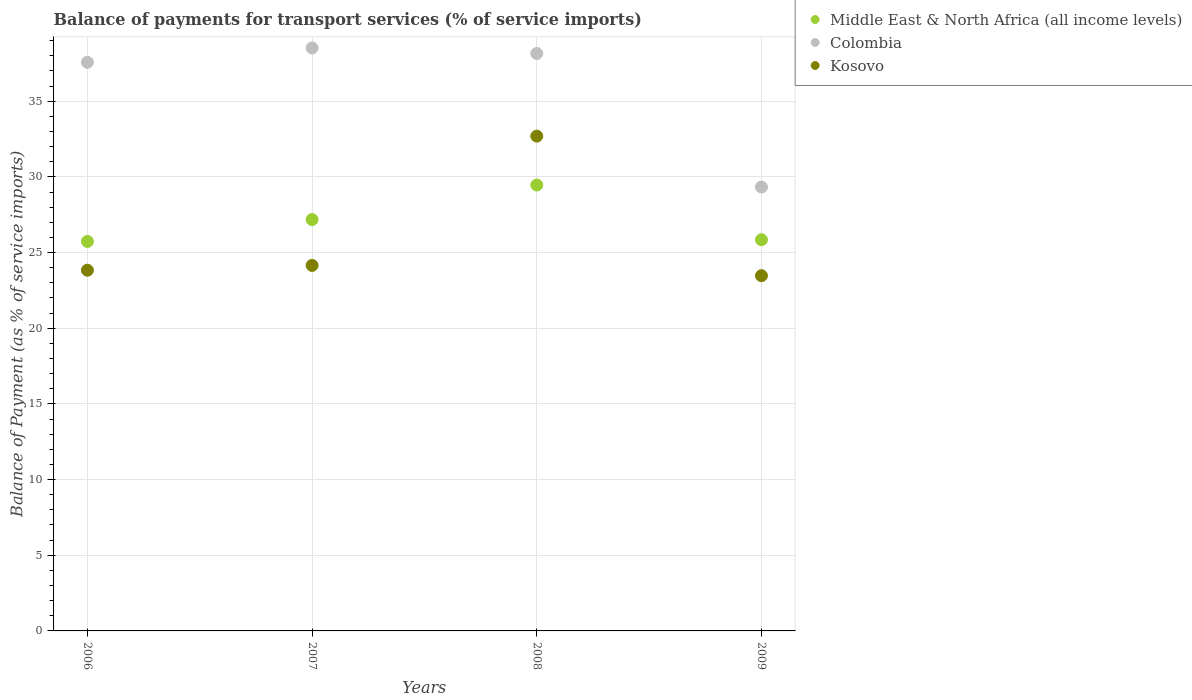How many different coloured dotlines are there?
Give a very brief answer. 3. What is the balance of payments for transport services in Middle East & North Africa (all income levels) in 2006?
Offer a terse response. 25.74. Across all years, what is the maximum balance of payments for transport services in Middle East & North Africa (all income levels)?
Your answer should be very brief. 29.46. Across all years, what is the minimum balance of payments for transport services in Kosovo?
Your response must be concise. 23.47. In which year was the balance of payments for transport services in Middle East & North Africa (all income levels) maximum?
Offer a very short reply. 2008. What is the total balance of payments for transport services in Colombia in the graph?
Provide a short and direct response. 143.58. What is the difference between the balance of payments for transport services in Middle East & North Africa (all income levels) in 2008 and that in 2009?
Provide a succinct answer. 3.61. What is the difference between the balance of payments for transport services in Middle East & North Africa (all income levels) in 2006 and the balance of payments for transport services in Colombia in 2009?
Ensure brevity in your answer.  -3.59. What is the average balance of payments for transport services in Kosovo per year?
Your response must be concise. 26.04. In the year 2009, what is the difference between the balance of payments for transport services in Middle East & North Africa (all income levels) and balance of payments for transport services in Colombia?
Your response must be concise. -3.48. What is the ratio of the balance of payments for transport services in Colombia in 2007 to that in 2008?
Give a very brief answer. 1.01. Is the difference between the balance of payments for transport services in Middle East & North Africa (all income levels) in 2008 and 2009 greater than the difference between the balance of payments for transport services in Colombia in 2008 and 2009?
Make the answer very short. No. What is the difference between the highest and the second highest balance of payments for transport services in Kosovo?
Make the answer very short. 8.54. What is the difference between the highest and the lowest balance of payments for transport services in Colombia?
Offer a terse response. 9.19. In how many years, is the balance of payments for transport services in Kosovo greater than the average balance of payments for transport services in Kosovo taken over all years?
Give a very brief answer. 1. Is the sum of the balance of payments for transport services in Middle East & North Africa (all income levels) in 2008 and 2009 greater than the maximum balance of payments for transport services in Colombia across all years?
Keep it short and to the point. Yes. Is it the case that in every year, the sum of the balance of payments for transport services in Colombia and balance of payments for transport services in Kosovo  is greater than the balance of payments for transport services in Middle East & North Africa (all income levels)?
Ensure brevity in your answer.  Yes. Does the balance of payments for transport services in Colombia monotonically increase over the years?
Offer a very short reply. No. Is the balance of payments for transport services in Colombia strictly greater than the balance of payments for transport services in Middle East & North Africa (all income levels) over the years?
Your response must be concise. Yes. What is the difference between two consecutive major ticks on the Y-axis?
Offer a very short reply. 5. Are the values on the major ticks of Y-axis written in scientific E-notation?
Give a very brief answer. No. How many legend labels are there?
Give a very brief answer. 3. What is the title of the graph?
Your response must be concise. Balance of payments for transport services (% of service imports). What is the label or title of the X-axis?
Keep it short and to the point. Years. What is the label or title of the Y-axis?
Keep it short and to the point. Balance of Payment (as % of service imports). What is the Balance of Payment (as % of service imports) in Middle East & North Africa (all income levels) in 2006?
Offer a very short reply. 25.74. What is the Balance of Payment (as % of service imports) of Colombia in 2006?
Offer a very short reply. 37.57. What is the Balance of Payment (as % of service imports) of Kosovo in 2006?
Your answer should be compact. 23.83. What is the Balance of Payment (as % of service imports) of Middle East & North Africa (all income levels) in 2007?
Keep it short and to the point. 27.18. What is the Balance of Payment (as % of service imports) in Colombia in 2007?
Give a very brief answer. 38.52. What is the Balance of Payment (as % of service imports) in Kosovo in 2007?
Keep it short and to the point. 24.15. What is the Balance of Payment (as % of service imports) in Middle East & North Africa (all income levels) in 2008?
Provide a succinct answer. 29.46. What is the Balance of Payment (as % of service imports) in Colombia in 2008?
Make the answer very short. 38.15. What is the Balance of Payment (as % of service imports) in Kosovo in 2008?
Offer a terse response. 32.7. What is the Balance of Payment (as % of service imports) in Middle East & North Africa (all income levels) in 2009?
Offer a very short reply. 25.85. What is the Balance of Payment (as % of service imports) in Colombia in 2009?
Your answer should be compact. 29.33. What is the Balance of Payment (as % of service imports) of Kosovo in 2009?
Provide a short and direct response. 23.47. Across all years, what is the maximum Balance of Payment (as % of service imports) in Middle East & North Africa (all income levels)?
Your answer should be compact. 29.46. Across all years, what is the maximum Balance of Payment (as % of service imports) of Colombia?
Give a very brief answer. 38.52. Across all years, what is the maximum Balance of Payment (as % of service imports) in Kosovo?
Keep it short and to the point. 32.7. Across all years, what is the minimum Balance of Payment (as % of service imports) in Middle East & North Africa (all income levels)?
Provide a short and direct response. 25.74. Across all years, what is the minimum Balance of Payment (as % of service imports) in Colombia?
Your response must be concise. 29.33. Across all years, what is the minimum Balance of Payment (as % of service imports) of Kosovo?
Offer a very short reply. 23.47. What is the total Balance of Payment (as % of service imports) of Middle East & North Africa (all income levels) in the graph?
Provide a succinct answer. 108.23. What is the total Balance of Payment (as % of service imports) in Colombia in the graph?
Your answer should be very brief. 143.58. What is the total Balance of Payment (as % of service imports) in Kosovo in the graph?
Keep it short and to the point. 104.15. What is the difference between the Balance of Payment (as % of service imports) in Middle East & North Africa (all income levels) in 2006 and that in 2007?
Give a very brief answer. -1.44. What is the difference between the Balance of Payment (as % of service imports) in Colombia in 2006 and that in 2007?
Offer a terse response. -0.95. What is the difference between the Balance of Payment (as % of service imports) in Kosovo in 2006 and that in 2007?
Provide a short and direct response. -0.32. What is the difference between the Balance of Payment (as % of service imports) of Middle East & North Africa (all income levels) in 2006 and that in 2008?
Give a very brief answer. -3.73. What is the difference between the Balance of Payment (as % of service imports) in Colombia in 2006 and that in 2008?
Offer a terse response. -0.58. What is the difference between the Balance of Payment (as % of service imports) of Kosovo in 2006 and that in 2008?
Keep it short and to the point. -8.86. What is the difference between the Balance of Payment (as % of service imports) in Middle East & North Africa (all income levels) in 2006 and that in 2009?
Your answer should be compact. -0.11. What is the difference between the Balance of Payment (as % of service imports) in Colombia in 2006 and that in 2009?
Give a very brief answer. 8.25. What is the difference between the Balance of Payment (as % of service imports) of Kosovo in 2006 and that in 2009?
Your response must be concise. 0.36. What is the difference between the Balance of Payment (as % of service imports) in Middle East & North Africa (all income levels) in 2007 and that in 2008?
Offer a very short reply. -2.28. What is the difference between the Balance of Payment (as % of service imports) in Colombia in 2007 and that in 2008?
Give a very brief answer. 0.37. What is the difference between the Balance of Payment (as % of service imports) in Kosovo in 2007 and that in 2008?
Provide a short and direct response. -8.54. What is the difference between the Balance of Payment (as % of service imports) in Middle East & North Africa (all income levels) in 2007 and that in 2009?
Your answer should be very brief. 1.33. What is the difference between the Balance of Payment (as % of service imports) of Colombia in 2007 and that in 2009?
Keep it short and to the point. 9.19. What is the difference between the Balance of Payment (as % of service imports) in Kosovo in 2007 and that in 2009?
Provide a succinct answer. 0.68. What is the difference between the Balance of Payment (as % of service imports) of Middle East & North Africa (all income levels) in 2008 and that in 2009?
Provide a succinct answer. 3.61. What is the difference between the Balance of Payment (as % of service imports) of Colombia in 2008 and that in 2009?
Your answer should be very brief. 8.83. What is the difference between the Balance of Payment (as % of service imports) of Kosovo in 2008 and that in 2009?
Give a very brief answer. 9.22. What is the difference between the Balance of Payment (as % of service imports) of Middle East & North Africa (all income levels) in 2006 and the Balance of Payment (as % of service imports) of Colombia in 2007?
Ensure brevity in your answer.  -12.78. What is the difference between the Balance of Payment (as % of service imports) of Middle East & North Africa (all income levels) in 2006 and the Balance of Payment (as % of service imports) of Kosovo in 2007?
Provide a succinct answer. 1.58. What is the difference between the Balance of Payment (as % of service imports) in Colombia in 2006 and the Balance of Payment (as % of service imports) in Kosovo in 2007?
Make the answer very short. 13.42. What is the difference between the Balance of Payment (as % of service imports) of Middle East & North Africa (all income levels) in 2006 and the Balance of Payment (as % of service imports) of Colombia in 2008?
Offer a very short reply. -12.42. What is the difference between the Balance of Payment (as % of service imports) of Middle East & North Africa (all income levels) in 2006 and the Balance of Payment (as % of service imports) of Kosovo in 2008?
Your answer should be compact. -6.96. What is the difference between the Balance of Payment (as % of service imports) in Colombia in 2006 and the Balance of Payment (as % of service imports) in Kosovo in 2008?
Provide a succinct answer. 4.88. What is the difference between the Balance of Payment (as % of service imports) of Middle East & North Africa (all income levels) in 2006 and the Balance of Payment (as % of service imports) of Colombia in 2009?
Give a very brief answer. -3.59. What is the difference between the Balance of Payment (as % of service imports) of Middle East & North Africa (all income levels) in 2006 and the Balance of Payment (as % of service imports) of Kosovo in 2009?
Your response must be concise. 2.26. What is the difference between the Balance of Payment (as % of service imports) of Colombia in 2006 and the Balance of Payment (as % of service imports) of Kosovo in 2009?
Give a very brief answer. 14.1. What is the difference between the Balance of Payment (as % of service imports) in Middle East & North Africa (all income levels) in 2007 and the Balance of Payment (as % of service imports) in Colombia in 2008?
Your answer should be very brief. -10.97. What is the difference between the Balance of Payment (as % of service imports) of Middle East & North Africa (all income levels) in 2007 and the Balance of Payment (as % of service imports) of Kosovo in 2008?
Your answer should be very brief. -5.52. What is the difference between the Balance of Payment (as % of service imports) in Colombia in 2007 and the Balance of Payment (as % of service imports) in Kosovo in 2008?
Your response must be concise. 5.82. What is the difference between the Balance of Payment (as % of service imports) in Middle East & North Africa (all income levels) in 2007 and the Balance of Payment (as % of service imports) in Colombia in 2009?
Make the answer very short. -2.15. What is the difference between the Balance of Payment (as % of service imports) of Middle East & North Africa (all income levels) in 2007 and the Balance of Payment (as % of service imports) of Kosovo in 2009?
Your response must be concise. 3.71. What is the difference between the Balance of Payment (as % of service imports) in Colombia in 2007 and the Balance of Payment (as % of service imports) in Kosovo in 2009?
Provide a succinct answer. 15.05. What is the difference between the Balance of Payment (as % of service imports) of Middle East & North Africa (all income levels) in 2008 and the Balance of Payment (as % of service imports) of Colombia in 2009?
Make the answer very short. 0.14. What is the difference between the Balance of Payment (as % of service imports) of Middle East & North Africa (all income levels) in 2008 and the Balance of Payment (as % of service imports) of Kosovo in 2009?
Provide a succinct answer. 5.99. What is the difference between the Balance of Payment (as % of service imports) in Colombia in 2008 and the Balance of Payment (as % of service imports) in Kosovo in 2009?
Your answer should be very brief. 14.68. What is the average Balance of Payment (as % of service imports) of Middle East & North Africa (all income levels) per year?
Ensure brevity in your answer.  27.06. What is the average Balance of Payment (as % of service imports) in Colombia per year?
Offer a terse response. 35.89. What is the average Balance of Payment (as % of service imports) of Kosovo per year?
Provide a short and direct response. 26.04. In the year 2006, what is the difference between the Balance of Payment (as % of service imports) of Middle East & North Africa (all income levels) and Balance of Payment (as % of service imports) of Colombia?
Provide a succinct answer. -11.84. In the year 2006, what is the difference between the Balance of Payment (as % of service imports) in Middle East & North Africa (all income levels) and Balance of Payment (as % of service imports) in Kosovo?
Ensure brevity in your answer.  1.9. In the year 2006, what is the difference between the Balance of Payment (as % of service imports) of Colombia and Balance of Payment (as % of service imports) of Kosovo?
Offer a terse response. 13.74. In the year 2007, what is the difference between the Balance of Payment (as % of service imports) in Middle East & North Africa (all income levels) and Balance of Payment (as % of service imports) in Colombia?
Ensure brevity in your answer.  -11.34. In the year 2007, what is the difference between the Balance of Payment (as % of service imports) of Middle East & North Africa (all income levels) and Balance of Payment (as % of service imports) of Kosovo?
Keep it short and to the point. 3.03. In the year 2007, what is the difference between the Balance of Payment (as % of service imports) in Colombia and Balance of Payment (as % of service imports) in Kosovo?
Your response must be concise. 14.37. In the year 2008, what is the difference between the Balance of Payment (as % of service imports) of Middle East & North Africa (all income levels) and Balance of Payment (as % of service imports) of Colombia?
Your answer should be compact. -8.69. In the year 2008, what is the difference between the Balance of Payment (as % of service imports) of Middle East & North Africa (all income levels) and Balance of Payment (as % of service imports) of Kosovo?
Ensure brevity in your answer.  -3.23. In the year 2008, what is the difference between the Balance of Payment (as % of service imports) in Colombia and Balance of Payment (as % of service imports) in Kosovo?
Provide a succinct answer. 5.46. In the year 2009, what is the difference between the Balance of Payment (as % of service imports) in Middle East & North Africa (all income levels) and Balance of Payment (as % of service imports) in Colombia?
Offer a very short reply. -3.48. In the year 2009, what is the difference between the Balance of Payment (as % of service imports) in Middle East & North Africa (all income levels) and Balance of Payment (as % of service imports) in Kosovo?
Keep it short and to the point. 2.38. In the year 2009, what is the difference between the Balance of Payment (as % of service imports) in Colombia and Balance of Payment (as % of service imports) in Kosovo?
Ensure brevity in your answer.  5.86. What is the ratio of the Balance of Payment (as % of service imports) of Middle East & North Africa (all income levels) in 2006 to that in 2007?
Your response must be concise. 0.95. What is the ratio of the Balance of Payment (as % of service imports) in Colombia in 2006 to that in 2007?
Your answer should be compact. 0.98. What is the ratio of the Balance of Payment (as % of service imports) of Middle East & North Africa (all income levels) in 2006 to that in 2008?
Make the answer very short. 0.87. What is the ratio of the Balance of Payment (as % of service imports) of Colombia in 2006 to that in 2008?
Provide a succinct answer. 0.98. What is the ratio of the Balance of Payment (as % of service imports) of Kosovo in 2006 to that in 2008?
Provide a succinct answer. 0.73. What is the ratio of the Balance of Payment (as % of service imports) in Colombia in 2006 to that in 2009?
Your answer should be very brief. 1.28. What is the ratio of the Balance of Payment (as % of service imports) of Kosovo in 2006 to that in 2009?
Provide a succinct answer. 1.02. What is the ratio of the Balance of Payment (as % of service imports) in Middle East & North Africa (all income levels) in 2007 to that in 2008?
Ensure brevity in your answer.  0.92. What is the ratio of the Balance of Payment (as % of service imports) in Colombia in 2007 to that in 2008?
Ensure brevity in your answer.  1.01. What is the ratio of the Balance of Payment (as % of service imports) of Kosovo in 2007 to that in 2008?
Keep it short and to the point. 0.74. What is the ratio of the Balance of Payment (as % of service imports) of Middle East & North Africa (all income levels) in 2007 to that in 2009?
Make the answer very short. 1.05. What is the ratio of the Balance of Payment (as % of service imports) of Colombia in 2007 to that in 2009?
Your answer should be very brief. 1.31. What is the ratio of the Balance of Payment (as % of service imports) of Kosovo in 2007 to that in 2009?
Keep it short and to the point. 1.03. What is the ratio of the Balance of Payment (as % of service imports) of Middle East & North Africa (all income levels) in 2008 to that in 2009?
Your answer should be very brief. 1.14. What is the ratio of the Balance of Payment (as % of service imports) of Colombia in 2008 to that in 2009?
Keep it short and to the point. 1.3. What is the ratio of the Balance of Payment (as % of service imports) in Kosovo in 2008 to that in 2009?
Provide a succinct answer. 1.39. What is the difference between the highest and the second highest Balance of Payment (as % of service imports) in Middle East & North Africa (all income levels)?
Your answer should be very brief. 2.28. What is the difference between the highest and the second highest Balance of Payment (as % of service imports) of Colombia?
Offer a terse response. 0.37. What is the difference between the highest and the second highest Balance of Payment (as % of service imports) in Kosovo?
Ensure brevity in your answer.  8.54. What is the difference between the highest and the lowest Balance of Payment (as % of service imports) in Middle East & North Africa (all income levels)?
Your answer should be compact. 3.73. What is the difference between the highest and the lowest Balance of Payment (as % of service imports) in Colombia?
Provide a short and direct response. 9.19. What is the difference between the highest and the lowest Balance of Payment (as % of service imports) of Kosovo?
Keep it short and to the point. 9.22. 